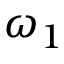Convert formula to latex. <formula><loc_0><loc_0><loc_500><loc_500>\omega _ { 1 }</formula> 